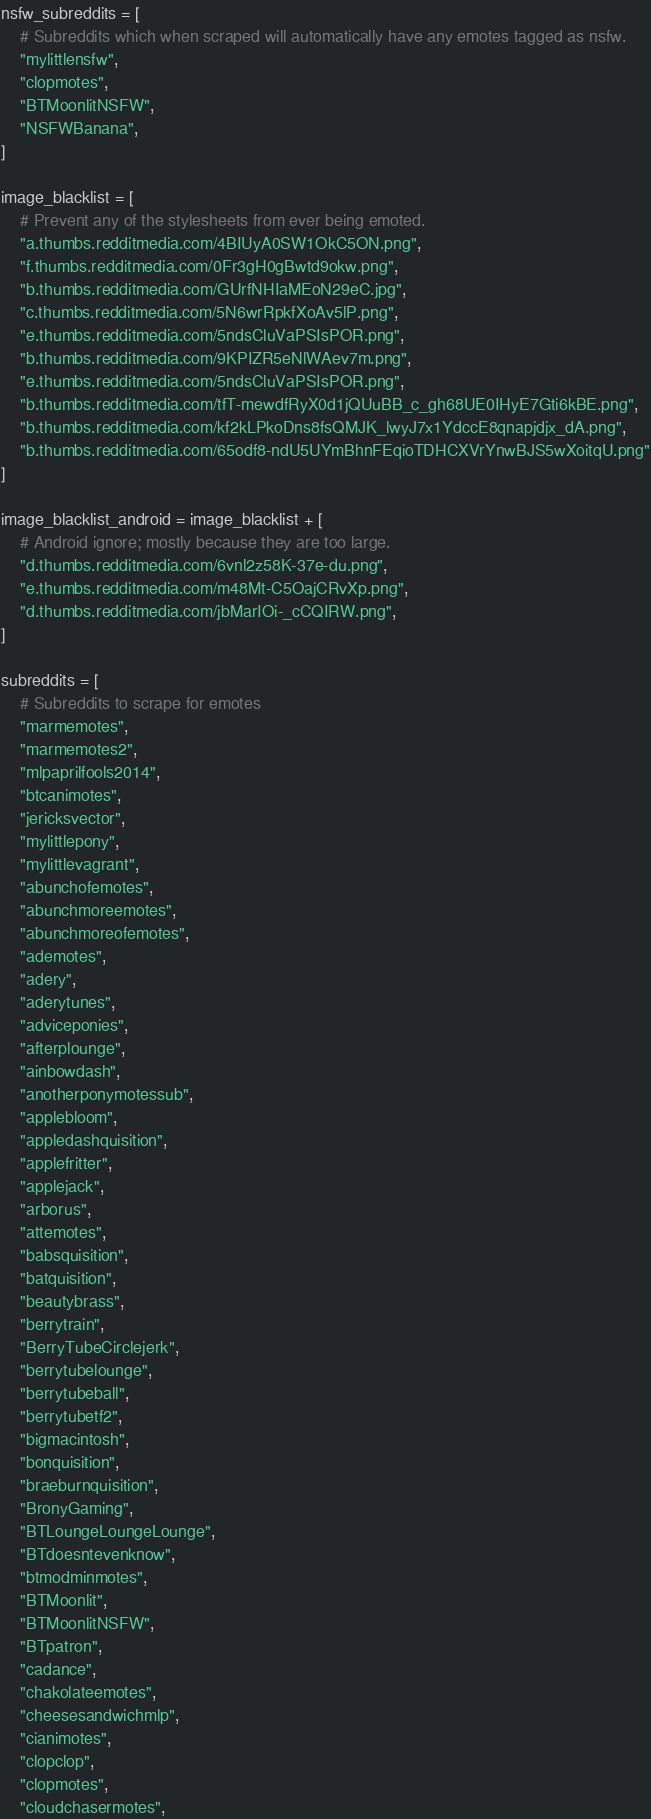Convert code to text. <code><loc_0><loc_0><loc_500><loc_500><_Python_>nsfw_subreddits = [
    # Subreddits which when scraped will automatically have any emotes tagged as nsfw.
    "mylittlensfw",
    "clopmotes",
    "BTMoonlitNSFW",
    "NSFWBanana",
]

image_blacklist = [
    # Prevent any of the stylesheets from ever being emoted.
    "a.thumbs.redditmedia.com/4BIUyA0SW1OkC5ON.png",
    "f.thumbs.redditmedia.com/0Fr3gH0gBwtd9okw.png",
    "b.thumbs.redditmedia.com/GUrfNHIaMEoN29eC.jpg",
    "c.thumbs.redditmedia.com/5N6wrRpkfXoAv5lP.png",
    "e.thumbs.redditmedia.com/5ndsCluVaPSIsPOR.png",
    "b.thumbs.redditmedia.com/9KPIZR5eNlWAev7m.png",
    "e.thumbs.redditmedia.com/5ndsCluVaPSIsPOR.png",
    "b.thumbs.redditmedia.com/tfT-mewdfRyX0d1jQUuBB_c_gh68UE0IHyE7Gti6kBE.png",
    "b.thumbs.redditmedia.com/kf2kLPkoDns8fsQMJK_lwyJ7x1YdccE8qnapjdjx_dA.png",
    "b.thumbs.redditmedia.com/65odf8-ndU5UYmBhnFEqioTDHCXVrYnwBJS5wXoitqU.png"
]

image_blacklist_android = image_blacklist + [
    # Android ignore; mostly because they are too large.
    "d.thumbs.redditmedia.com/6vnl2z58K-37e-du.png",
    "e.thumbs.redditmedia.com/m48Mt-C5OajCRvXp.png",
    "d.thumbs.redditmedia.com/jbMarIOi-_cCQIRW.png",
]

subreddits = [
    # Subreddits to scrape for emotes
    "marmemotes",
    "marmemotes2",
    "mlpaprilfools2014",
    "btcanimotes",
    "jericksvector",
    "mylittlepony",
    "mylittlevagrant",
    "abunchofemotes",
    "abunchmoreemotes",
    "abunchmoreofemotes",
    "ademotes",
    "adery",
    "aderytunes",
    "adviceponies",
    "afterplounge",
    "ainbowdash",
    "anotherponymotessub",
    "applebloom",
    "appledashquisition",
    "applefritter",
    "applejack",
    "arborus",
    "attemotes",
    "babsquisition",
    "batquisition",
    "beautybrass",
    "berrytrain",
    "BerryTubeCirclejerk",
    "berrytubelounge",
    "berrytubeball",
    "berrytubetf2",
    "bigmacintosh",
    "bonquisition",
    "braeburnquisition",
    "BronyGaming",
    "BTLoungeLoungeLounge",
    "BTdoesntevenknow",
    "btmodminmotes",
    "BTMoonlit",
    "BTMoonlitNSFW",
    "BTpatron",
    "cadance",
    "chakolateemotes",
    "cheesesandwichmlp",
    "cianimotes",
    "clopclop",
    "clopmotes",
    "cloudchasermotes",</code> 